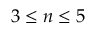Convert formula to latex. <formula><loc_0><loc_0><loc_500><loc_500>3 \leq n \leq 5</formula> 